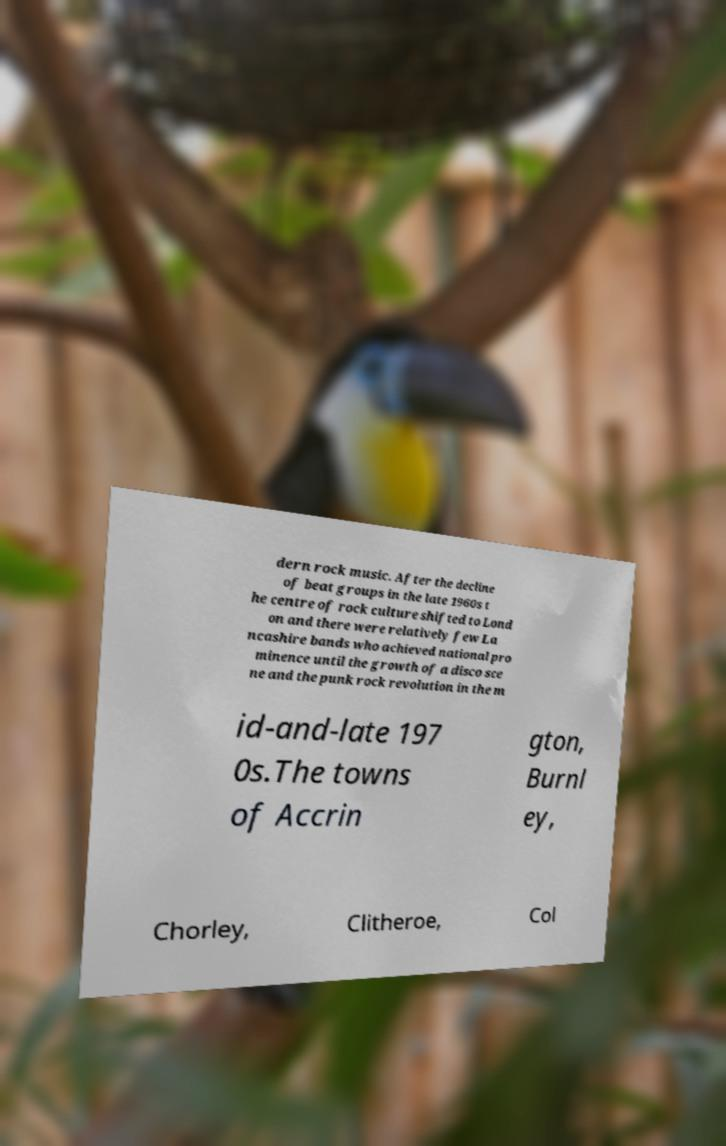Please identify and transcribe the text found in this image. dern rock music. After the decline of beat groups in the late 1960s t he centre of rock culture shifted to Lond on and there were relatively few La ncashire bands who achieved national pro minence until the growth of a disco sce ne and the punk rock revolution in the m id-and-late 197 0s.The towns of Accrin gton, Burnl ey, Chorley, Clitheroe, Col 